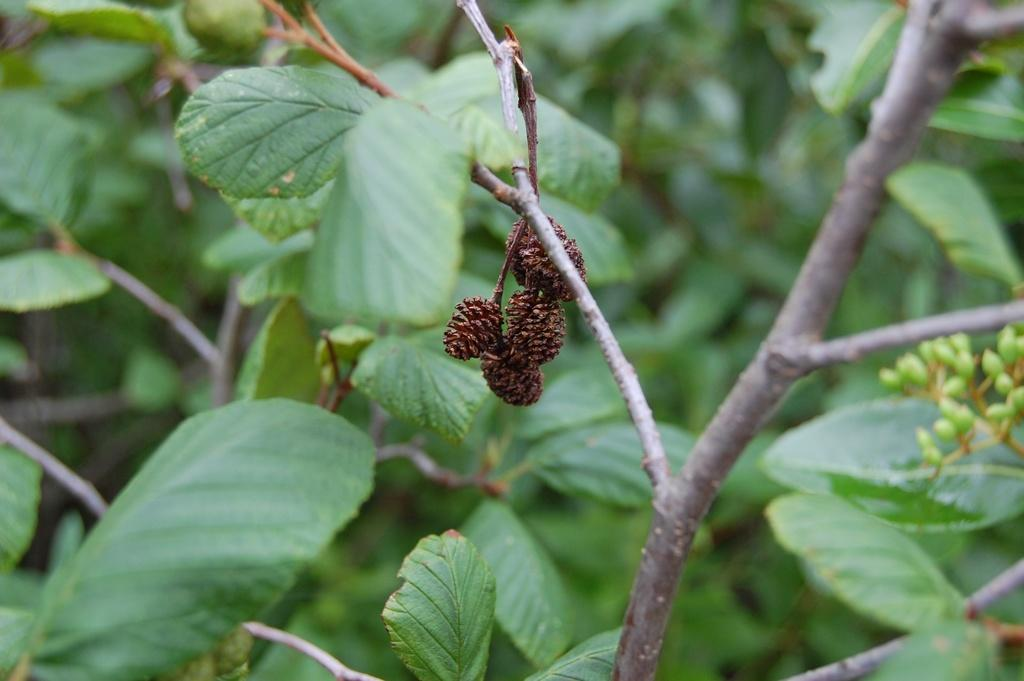What type of living organisms can be seen in the image? Plants can be seen in the image. What is hanging in the center of the image? There is a fruit hanging in the center of the image. Can you see any ink on the plants in the image? There is no ink present on the plants in the image. How does the time of day affect the appearance of the plants in the image? The provided facts do not mention the time of day, so we cannot determine how it affects the appearance of the plants in the image. 